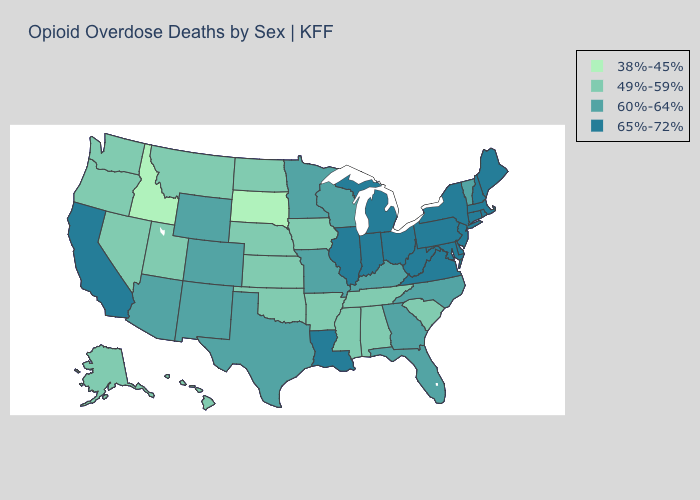How many symbols are there in the legend?
Concise answer only. 4. What is the highest value in states that border Rhode Island?
Give a very brief answer. 65%-72%. What is the value of California?
Give a very brief answer. 65%-72%. What is the highest value in the MidWest ?
Short answer required. 65%-72%. Does Washington have the highest value in the West?
Keep it brief. No. Name the states that have a value in the range 65%-72%?
Be succinct. California, Connecticut, Delaware, Illinois, Indiana, Louisiana, Maine, Maryland, Massachusetts, Michigan, New Hampshire, New Jersey, New York, Ohio, Pennsylvania, Rhode Island, Virginia, West Virginia. What is the value of Oklahoma?
Answer briefly. 49%-59%. Name the states that have a value in the range 49%-59%?
Be succinct. Alabama, Alaska, Arkansas, Hawaii, Iowa, Kansas, Mississippi, Montana, Nebraska, Nevada, North Dakota, Oklahoma, Oregon, South Carolina, Tennessee, Utah, Washington. Among the states that border Colorado , does Utah have the highest value?
Write a very short answer. No. Among the states that border Pennsylvania , which have the lowest value?
Quick response, please. Delaware, Maryland, New Jersey, New York, Ohio, West Virginia. What is the lowest value in the USA?
Answer briefly. 38%-45%. Does South Dakota have the lowest value in the USA?
Give a very brief answer. Yes. Which states hav the highest value in the MidWest?
Concise answer only. Illinois, Indiana, Michigan, Ohio. Which states hav the highest value in the South?
Quick response, please. Delaware, Louisiana, Maryland, Virginia, West Virginia. What is the lowest value in states that border Oregon?
Answer briefly. 38%-45%. 